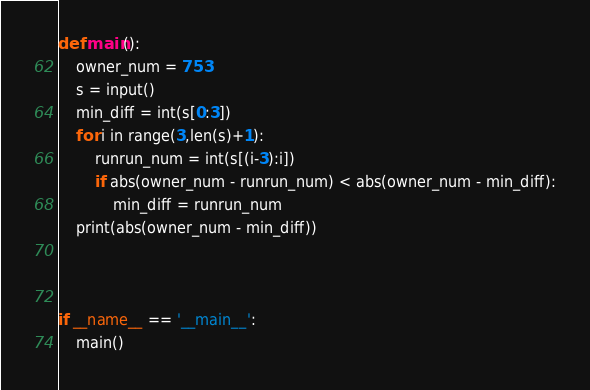Convert code to text. <code><loc_0><loc_0><loc_500><loc_500><_Python_>def main():
    owner_num = 753
    s = input()
    min_diff = int(s[0:3])
    for i in range(3,len(s)+1):
        runrun_num = int(s[(i-3):i])
        if abs(owner_num - runrun_num) < abs(owner_num - min_diff):
            min_diff = runrun_num
    print(abs(owner_num - min_diff))



if __name__ == '__main__':
    main()
</code> 